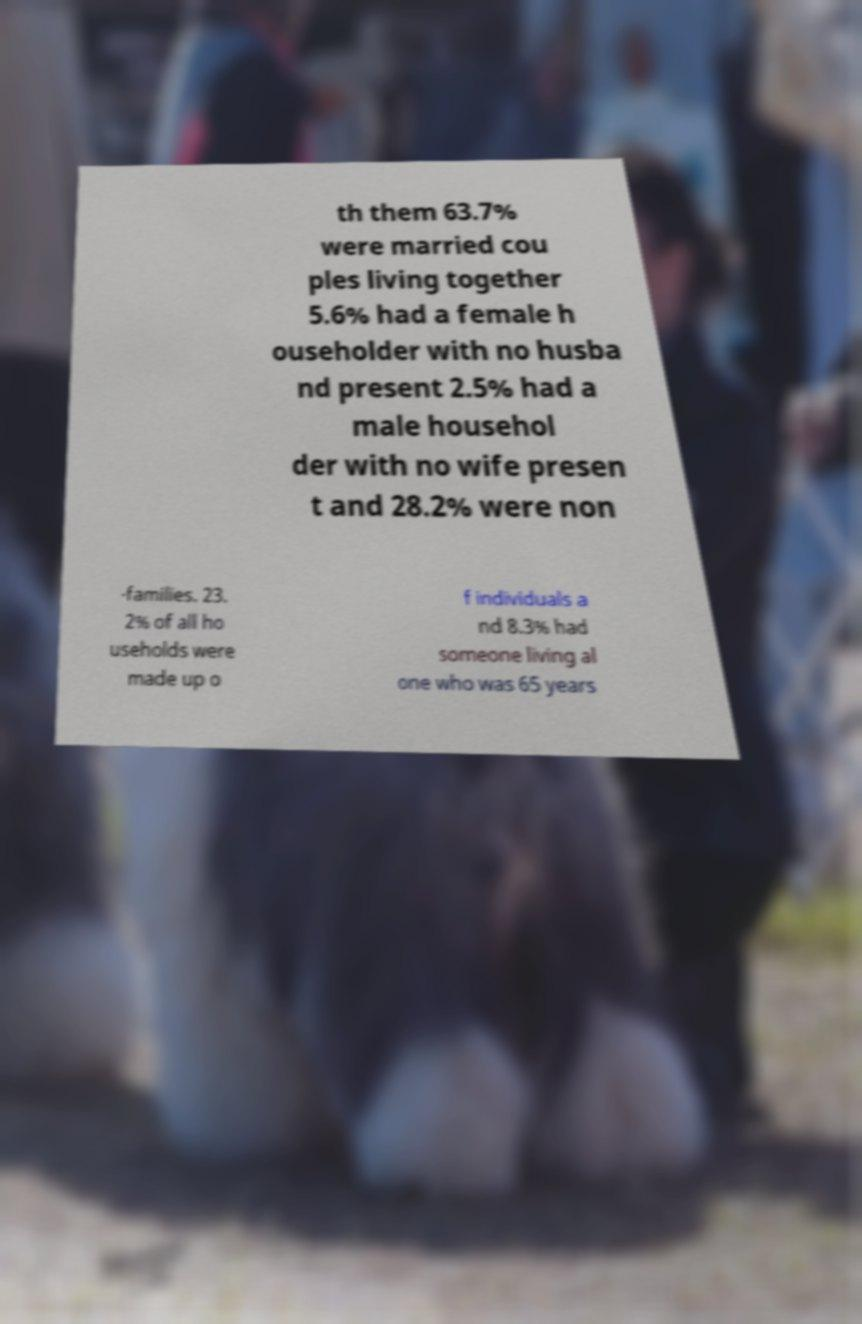Can you accurately transcribe the text from the provided image for me? th them 63.7% were married cou ples living together 5.6% had a female h ouseholder with no husba nd present 2.5% had a male househol der with no wife presen t and 28.2% were non -families. 23. 2% of all ho useholds were made up o f individuals a nd 8.3% had someone living al one who was 65 years 